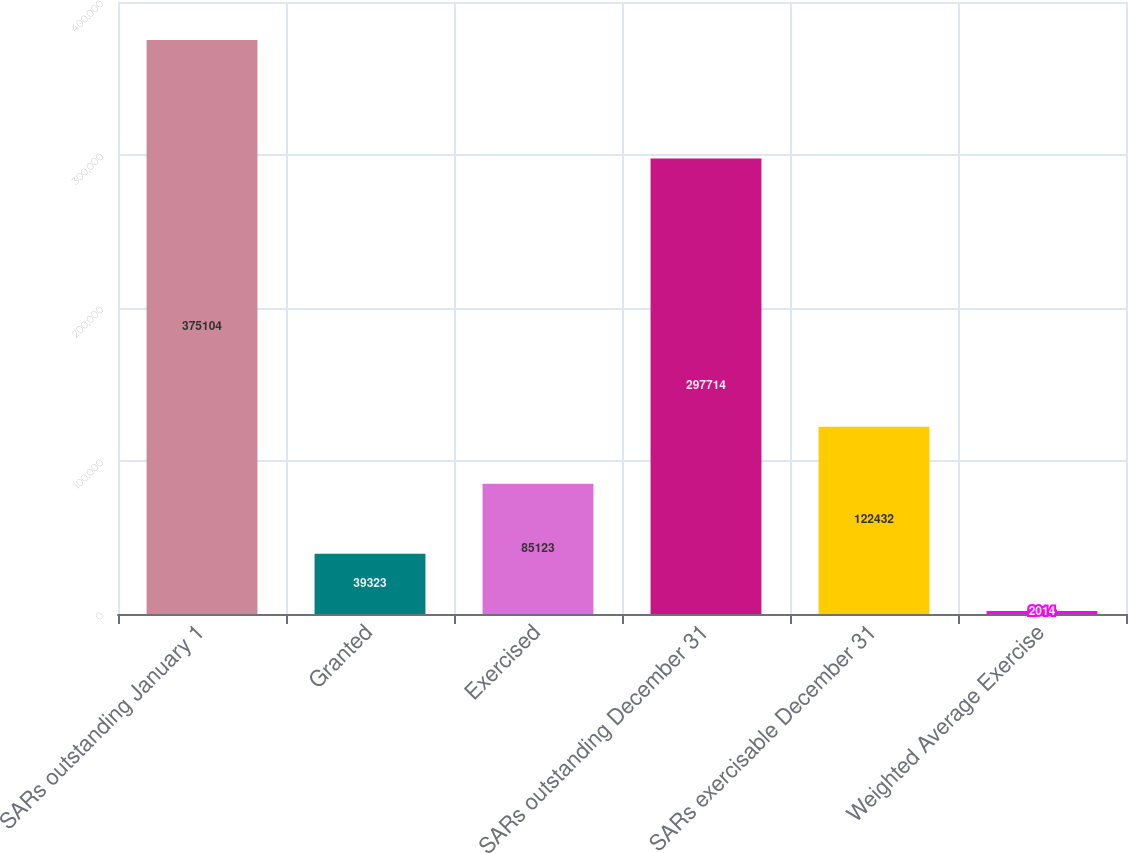<chart> <loc_0><loc_0><loc_500><loc_500><bar_chart><fcel>SARs outstanding January 1<fcel>Granted<fcel>Exercised<fcel>SARs outstanding December 31<fcel>SARs exercisable December 31<fcel>Weighted Average Exercise<nl><fcel>375104<fcel>39323<fcel>85123<fcel>297714<fcel>122432<fcel>2014<nl></chart> 